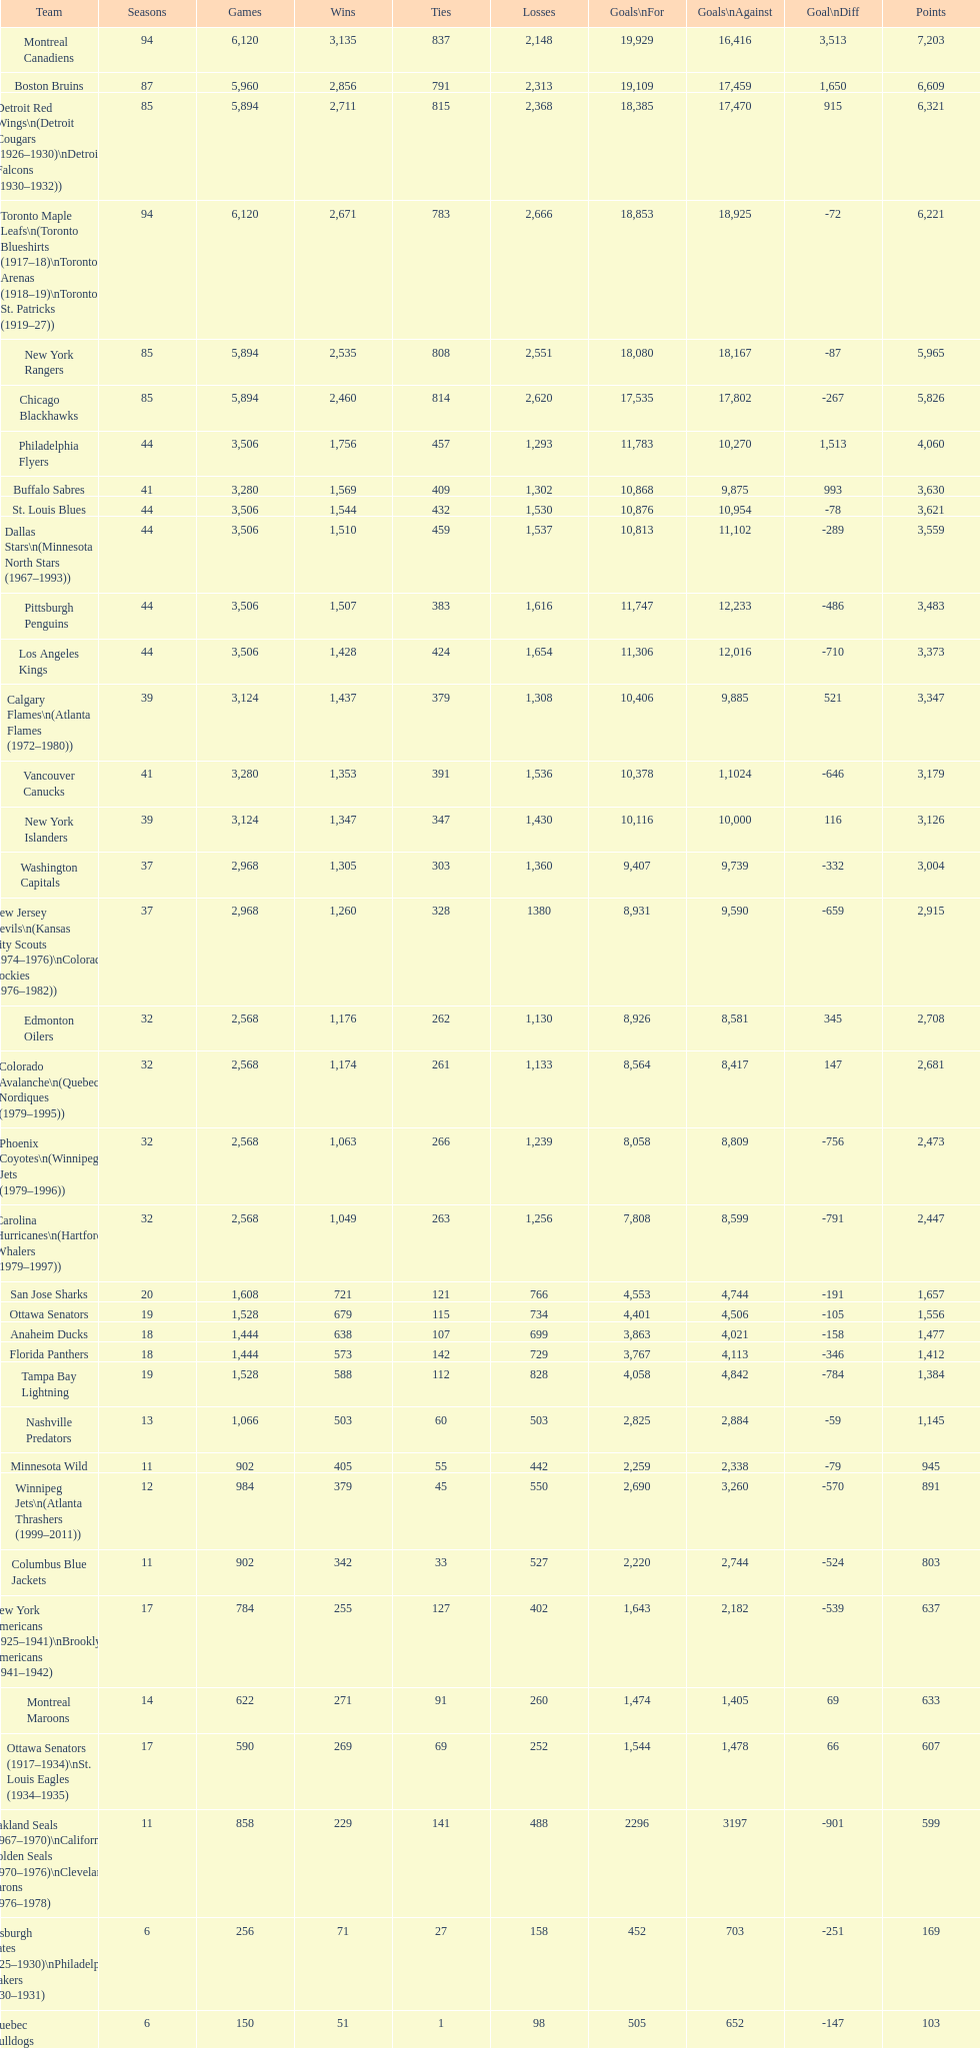Who is at the top of the list? Montreal Canadiens. Give me the full table as a dictionary. {'header': ['Team', 'Seasons', 'Games', 'Wins', 'Ties', 'Losses', 'Goals\\nFor', 'Goals\\nAgainst', 'Goal\\nDiff', 'Points'], 'rows': [['Montreal Canadiens', '94', '6,120', '3,135', '837', '2,148', '19,929', '16,416', '3,513', '7,203'], ['Boston Bruins', '87', '5,960', '2,856', '791', '2,313', '19,109', '17,459', '1,650', '6,609'], ['Detroit Red Wings\\n(Detroit Cougars (1926–1930)\\nDetroit Falcons (1930–1932))', '85', '5,894', '2,711', '815', '2,368', '18,385', '17,470', '915', '6,321'], ['Toronto Maple Leafs\\n(Toronto Blueshirts (1917–18)\\nToronto Arenas (1918–19)\\nToronto St. Patricks (1919–27))', '94', '6,120', '2,671', '783', '2,666', '18,853', '18,925', '-72', '6,221'], ['New York Rangers', '85', '5,894', '2,535', '808', '2,551', '18,080', '18,167', '-87', '5,965'], ['Chicago Blackhawks', '85', '5,894', '2,460', '814', '2,620', '17,535', '17,802', '-267', '5,826'], ['Philadelphia Flyers', '44', '3,506', '1,756', '457', '1,293', '11,783', '10,270', '1,513', '4,060'], ['Buffalo Sabres', '41', '3,280', '1,569', '409', '1,302', '10,868', '9,875', '993', '3,630'], ['St. Louis Blues', '44', '3,506', '1,544', '432', '1,530', '10,876', '10,954', '-78', '3,621'], ['Dallas Stars\\n(Minnesota North Stars (1967–1993))', '44', '3,506', '1,510', '459', '1,537', '10,813', '11,102', '-289', '3,559'], ['Pittsburgh Penguins', '44', '3,506', '1,507', '383', '1,616', '11,747', '12,233', '-486', '3,483'], ['Los Angeles Kings', '44', '3,506', '1,428', '424', '1,654', '11,306', '12,016', '-710', '3,373'], ['Calgary Flames\\n(Atlanta Flames (1972–1980))', '39', '3,124', '1,437', '379', '1,308', '10,406', '9,885', '521', '3,347'], ['Vancouver Canucks', '41', '3,280', '1,353', '391', '1,536', '10,378', '1,1024', '-646', '3,179'], ['New York Islanders', '39', '3,124', '1,347', '347', '1,430', '10,116', '10,000', '116', '3,126'], ['Washington Capitals', '37', '2,968', '1,305', '303', '1,360', '9,407', '9,739', '-332', '3,004'], ['New Jersey Devils\\n(Kansas City Scouts (1974–1976)\\nColorado Rockies (1976–1982))', '37', '2,968', '1,260', '328', '1380', '8,931', '9,590', '-659', '2,915'], ['Edmonton Oilers', '32', '2,568', '1,176', '262', '1,130', '8,926', '8,581', '345', '2,708'], ['Colorado Avalanche\\n(Quebec Nordiques (1979–1995))', '32', '2,568', '1,174', '261', '1,133', '8,564', '8,417', '147', '2,681'], ['Phoenix Coyotes\\n(Winnipeg Jets (1979–1996))', '32', '2,568', '1,063', '266', '1,239', '8,058', '8,809', '-756', '2,473'], ['Carolina Hurricanes\\n(Hartford Whalers (1979–1997))', '32', '2,568', '1,049', '263', '1,256', '7,808', '8,599', '-791', '2,447'], ['San Jose Sharks', '20', '1,608', '721', '121', '766', '4,553', '4,744', '-191', '1,657'], ['Ottawa Senators', '19', '1,528', '679', '115', '734', '4,401', '4,506', '-105', '1,556'], ['Anaheim Ducks', '18', '1,444', '638', '107', '699', '3,863', '4,021', '-158', '1,477'], ['Florida Panthers', '18', '1,444', '573', '142', '729', '3,767', '4,113', '-346', '1,412'], ['Tampa Bay Lightning', '19', '1,528', '588', '112', '828', '4,058', '4,842', '-784', '1,384'], ['Nashville Predators', '13', '1,066', '503', '60', '503', '2,825', '2,884', '-59', '1,145'], ['Minnesota Wild', '11', '902', '405', '55', '442', '2,259', '2,338', '-79', '945'], ['Winnipeg Jets\\n(Atlanta Thrashers (1999–2011))', '12', '984', '379', '45', '550', '2,690', '3,260', '-570', '891'], ['Columbus Blue Jackets', '11', '902', '342', '33', '527', '2,220', '2,744', '-524', '803'], ['New York Americans (1925–1941)\\nBrooklyn Americans (1941–1942)', '17', '784', '255', '127', '402', '1,643', '2,182', '-539', '637'], ['Montreal Maroons', '14', '622', '271', '91', '260', '1,474', '1,405', '69', '633'], ['Ottawa Senators (1917–1934)\\nSt. Louis Eagles (1934–1935)', '17', '590', '269', '69', '252', '1,544', '1,478', '66', '607'], ['Oakland Seals (1967–1970)\\nCalifornia Golden Seals (1970–1976)\\nCleveland Barons (1976–1978)', '11', '858', '229', '141', '488', '2296', '3197', '-901', '599'], ['Pittsburgh Pirates (1925–1930)\\nPhiladelphia Quakers (1930–1931)', '6', '256', '71', '27', '158', '452', '703', '-251', '169'], ['Quebec Bulldogs (1919–1920)\\nHamilton Tigers (1920–1925)', '6', '150', '51', '1', '98', '505', '652', '-147', '103'], ['Montreal Wanderers', '1', '6', '1', '0', '5', '17', '35', '-18', '2']]} 